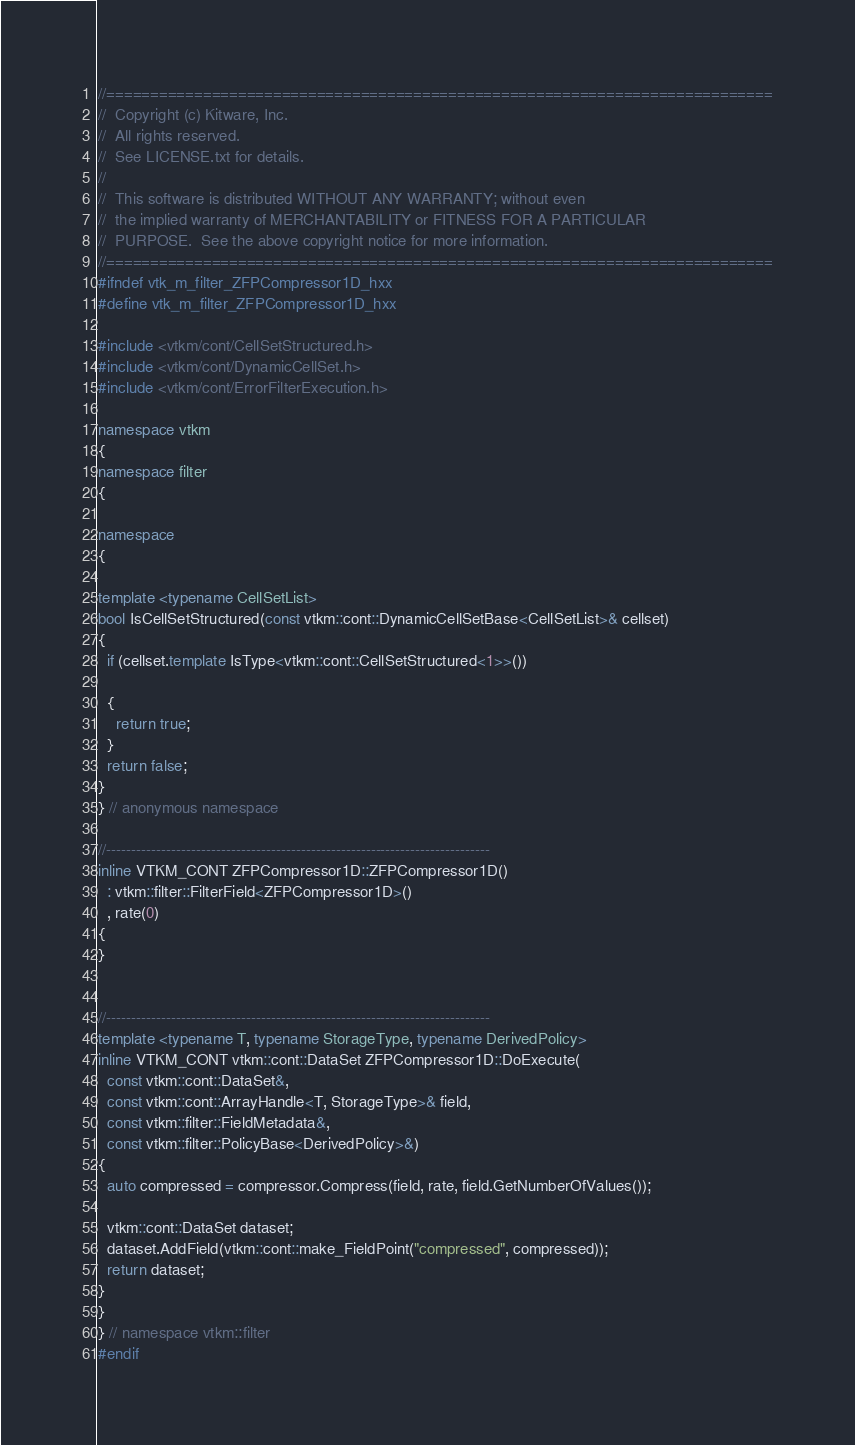Convert code to text. <code><loc_0><loc_0><loc_500><loc_500><_C++_>//============================================================================
//  Copyright (c) Kitware, Inc.
//  All rights reserved.
//  See LICENSE.txt for details.
//
//  This software is distributed WITHOUT ANY WARRANTY; without even
//  the implied warranty of MERCHANTABILITY or FITNESS FOR A PARTICULAR
//  PURPOSE.  See the above copyright notice for more information.
//============================================================================
#ifndef vtk_m_filter_ZFPCompressor1D_hxx
#define vtk_m_filter_ZFPCompressor1D_hxx

#include <vtkm/cont/CellSetStructured.h>
#include <vtkm/cont/DynamicCellSet.h>
#include <vtkm/cont/ErrorFilterExecution.h>

namespace vtkm
{
namespace filter
{

namespace
{

template <typename CellSetList>
bool IsCellSetStructured(const vtkm::cont::DynamicCellSetBase<CellSetList>& cellset)
{
  if (cellset.template IsType<vtkm::cont::CellSetStructured<1>>())

  {
    return true;
  }
  return false;
}
} // anonymous namespace

//-----------------------------------------------------------------------------
inline VTKM_CONT ZFPCompressor1D::ZFPCompressor1D()
  : vtkm::filter::FilterField<ZFPCompressor1D>()
  , rate(0)
{
}


//-----------------------------------------------------------------------------
template <typename T, typename StorageType, typename DerivedPolicy>
inline VTKM_CONT vtkm::cont::DataSet ZFPCompressor1D::DoExecute(
  const vtkm::cont::DataSet&,
  const vtkm::cont::ArrayHandle<T, StorageType>& field,
  const vtkm::filter::FieldMetadata&,
  const vtkm::filter::PolicyBase<DerivedPolicy>&)
{
  auto compressed = compressor.Compress(field, rate, field.GetNumberOfValues());

  vtkm::cont::DataSet dataset;
  dataset.AddField(vtkm::cont::make_FieldPoint("compressed", compressed));
  return dataset;
}
}
} // namespace vtkm::filter
#endif
</code> 